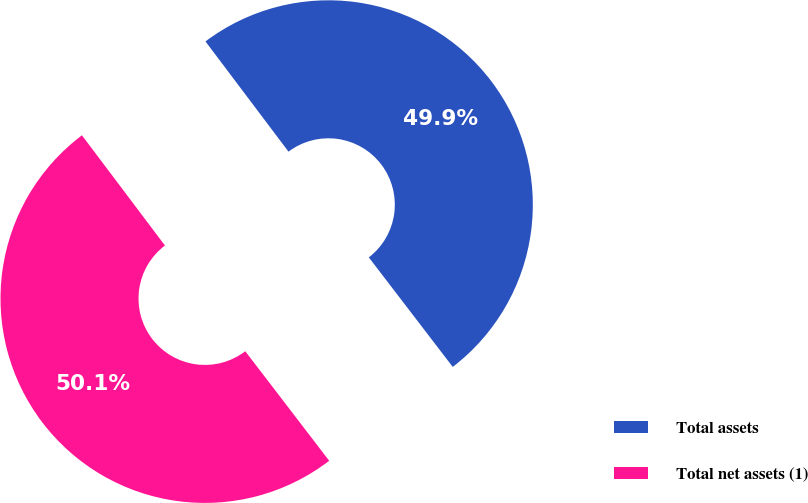Convert chart to OTSL. <chart><loc_0><loc_0><loc_500><loc_500><pie_chart><fcel>Total assets<fcel>Total net assets (1)<nl><fcel>49.87%<fcel>50.13%<nl></chart> 